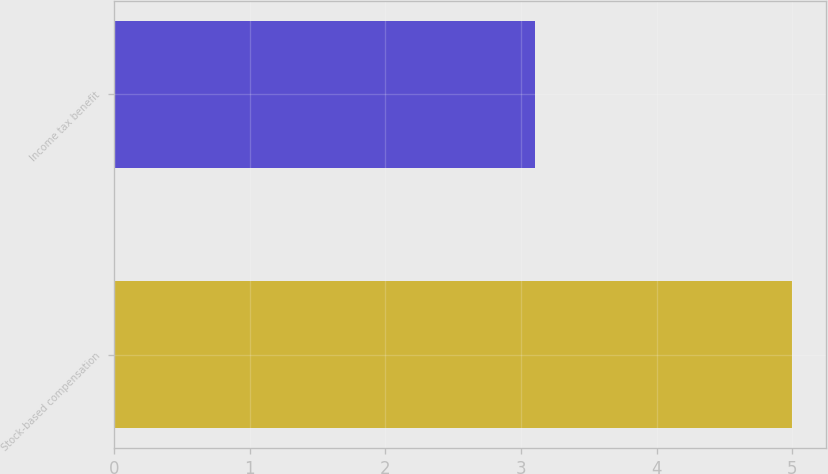Convert chart to OTSL. <chart><loc_0><loc_0><loc_500><loc_500><bar_chart><fcel>Stock-based compensation<fcel>Income tax benefit<nl><fcel>5<fcel>3.1<nl></chart> 